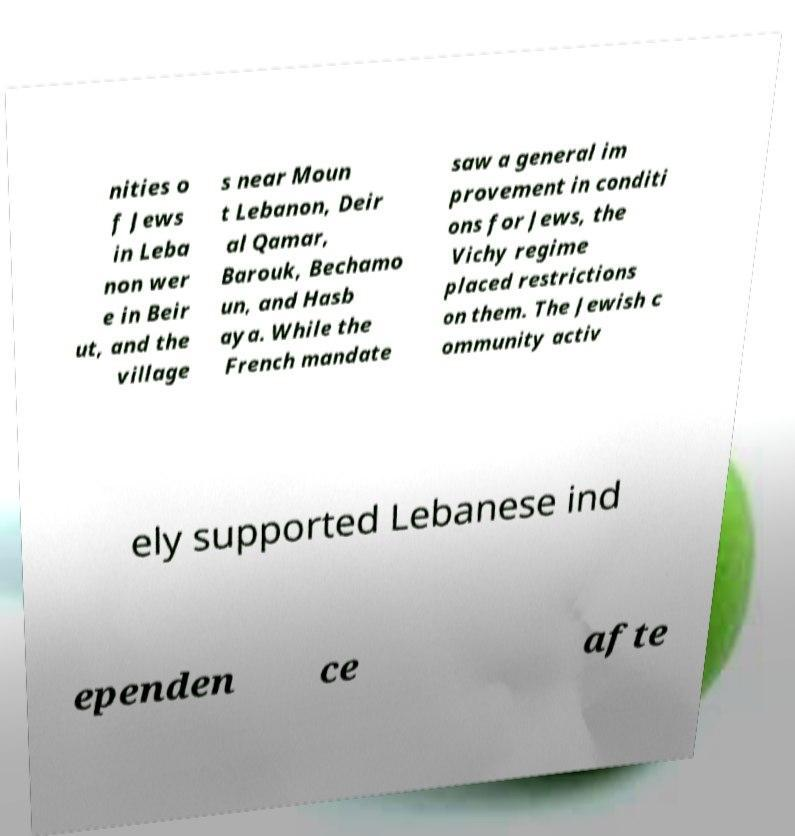For documentation purposes, I need the text within this image transcribed. Could you provide that? nities o f Jews in Leba non wer e in Beir ut, and the village s near Moun t Lebanon, Deir al Qamar, Barouk, Bechamo un, and Hasb aya. While the French mandate saw a general im provement in conditi ons for Jews, the Vichy regime placed restrictions on them. The Jewish c ommunity activ ely supported Lebanese ind ependen ce afte 